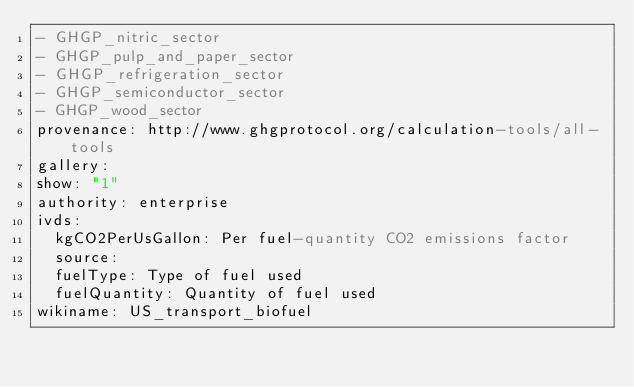<code> <loc_0><loc_0><loc_500><loc_500><_YAML_>- GHGP_nitric_sector
- GHGP_pulp_and_paper_sector
- GHGP_refrigeration_sector
- GHGP_semiconductor_sector
- GHGP_wood_sector
provenance: http://www.ghgprotocol.org/calculation-tools/all-tools
gallery: 
show: "1"
authority: enterprise
ivds: 
  kgCO2PerUsGallon: Per fuel-quantity CO2 emissions factor
  source: 
  fuelType: Type of fuel used
  fuelQuantity: Quantity of fuel used
wikiname: US_transport_biofuel
</code> 